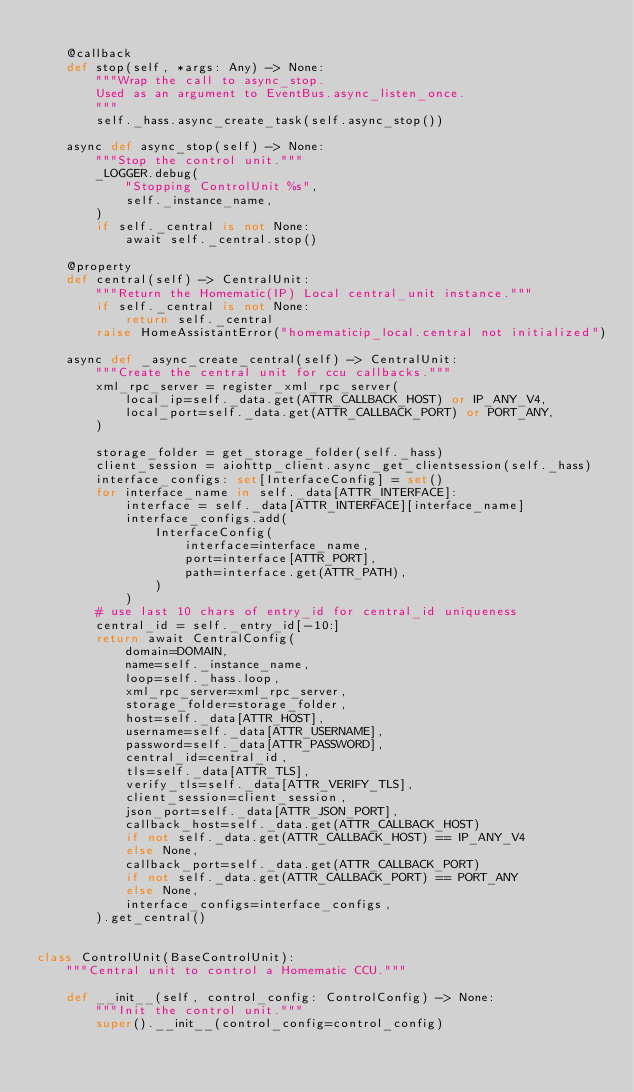<code> <loc_0><loc_0><loc_500><loc_500><_Python_>
    @callback
    def stop(self, *args: Any) -> None:
        """Wrap the call to async_stop.
        Used as an argument to EventBus.async_listen_once.
        """
        self._hass.async_create_task(self.async_stop())

    async def async_stop(self) -> None:
        """Stop the control unit."""
        _LOGGER.debug(
            "Stopping ControlUnit %s",
            self._instance_name,
        )
        if self._central is not None:
            await self._central.stop()

    @property
    def central(self) -> CentralUnit:
        """Return the Homematic(IP) Local central_unit instance."""
        if self._central is not None:
            return self._central
        raise HomeAssistantError("homematicip_local.central not initialized")

    async def _async_create_central(self) -> CentralUnit:
        """Create the central unit for ccu callbacks."""
        xml_rpc_server = register_xml_rpc_server(
            local_ip=self._data.get(ATTR_CALLBACK_HOST) or IP_ANY_V4,
            local_port=self._data.get(ATTR_CALLBACK_PORT) or PORT_ANY,
        )

        storage_folder = get_storage_folder(self._hass)
        client_session = aiohttp_client.async_get_clientsession(self._hass)
        interface_configs: set[InterfaceConfig] = set()
        for interface_name in self._data[ATTR_INTERFACE]:
            interface = self._data[ATTR_INTERFACE][interface_name]
            interface_configs.add(
                InterfaceConfig(
                    interface=interface_name,
                    port=interface[ATTR_PORT],
                    path=interface.get(ATTR_PATH),
                )
            )
        # use last 10 chars of entry_id for central_id uniqueness
        central_id = self._entry_id[-10:]
        return await CentralConfig(
            domain=DOMAIN,
            name=self._instance_name,
            loop=self._hass.loop,
            xml_rpc_server=xml_rpc_server,
            storage_folder=storage_folder,
            host=self._data[ATTR_HOST],
            username=self._data[ATTR_USERNAME],
            password=self._data[ATTR_PASSWORD],
            central_id=central_id,
            tls=self._data[ATTR_TLS],
            verify_tls=self._data[ATTR_VERIFY_TLS],
            client_session=client_session,
            json_port=self._data[ATTR_JSON_PORT],
            callback_host=self._data.get(ATTR_CALLBACK_HOST)
            if not self._data.get(ATTR_CALLBACK_HOST) == IP_ANY_V4
            else None,
            callback_port=self._data.get(ATTR_CALLBACK_PORT)
            if not self._data.get(ATTR_CALLBACK_PORT) == PORT_ANY
            else None,
            interface_configs=interface_configs,
        ).get_central()


class ControlUnit(BaseControlUnit):
    """Central unit to control a Homematic CCU."""

    def __init__(self, control_config: ControlConfig) -> None:
        """Init the control unit."""
        super().__init__(control_config=control_config)</code> 